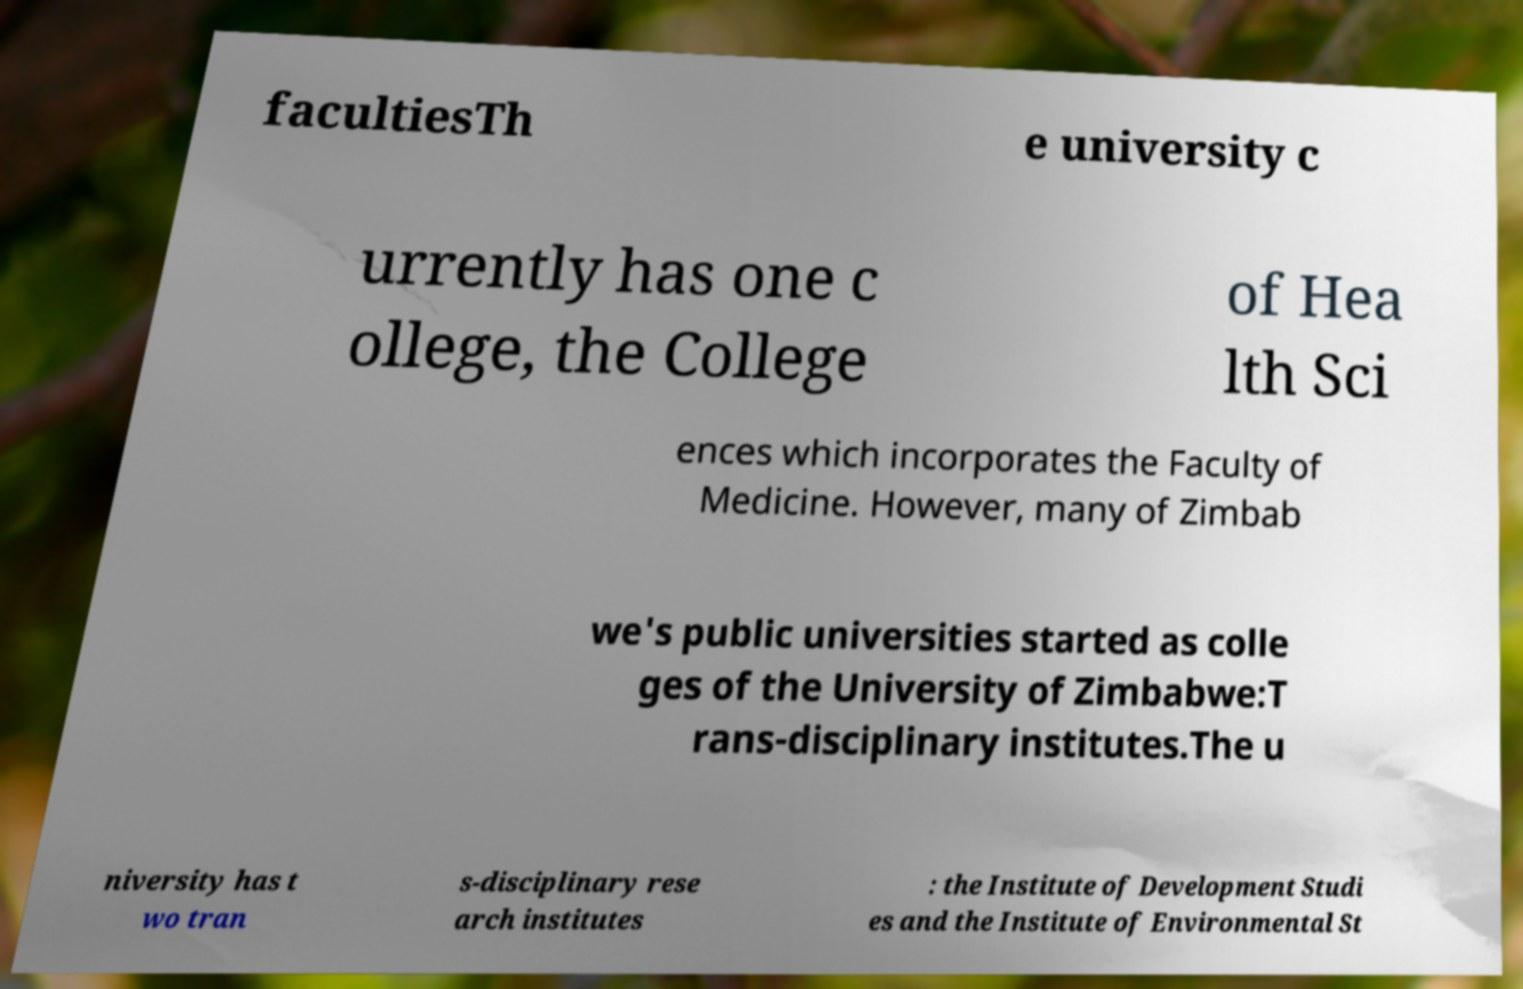Please read and relay the text visible in this image. What does it say? facultiesTh e university c urrently has one c ollege, the College of Hea lth Sci ences which incorporates the Faculty of Medicine. However, many of Zimbab we's public universities started as colle ges of the University of Zimbabwe:T rans-disciplinary institutes.The u niversity has t wo tran s-disciplinary rese arch institutes : the Institute of Development Studi es and the Institute of Environmental St 